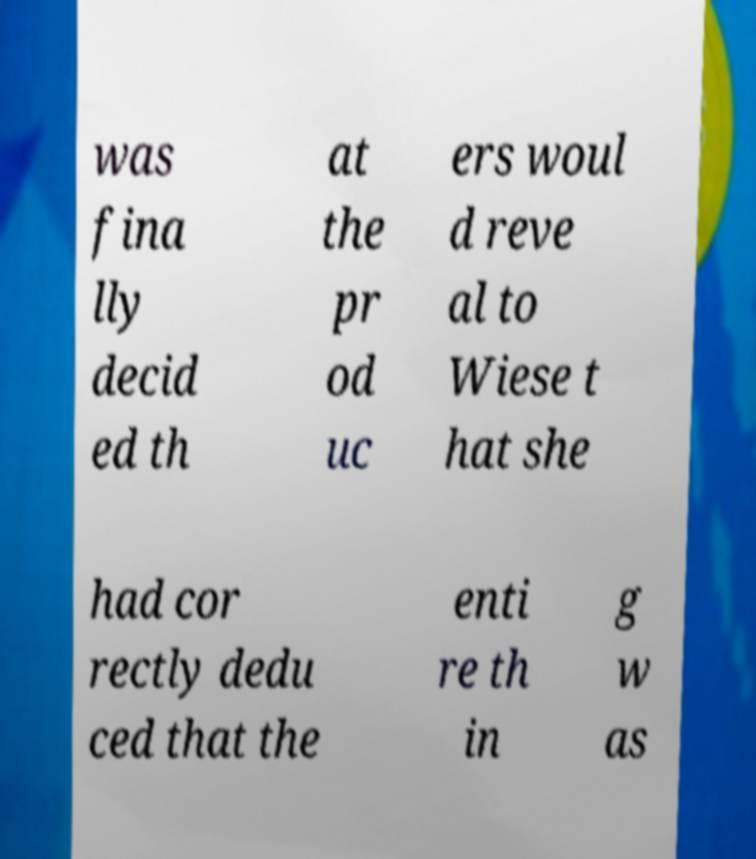I need the written content from this picture converted into text. Can you do that? was fina lly decid ed th at the pr od uc ers woul d reve al to Wiese t hat she had cor rectly dedu ced that the enti re th in g w as 